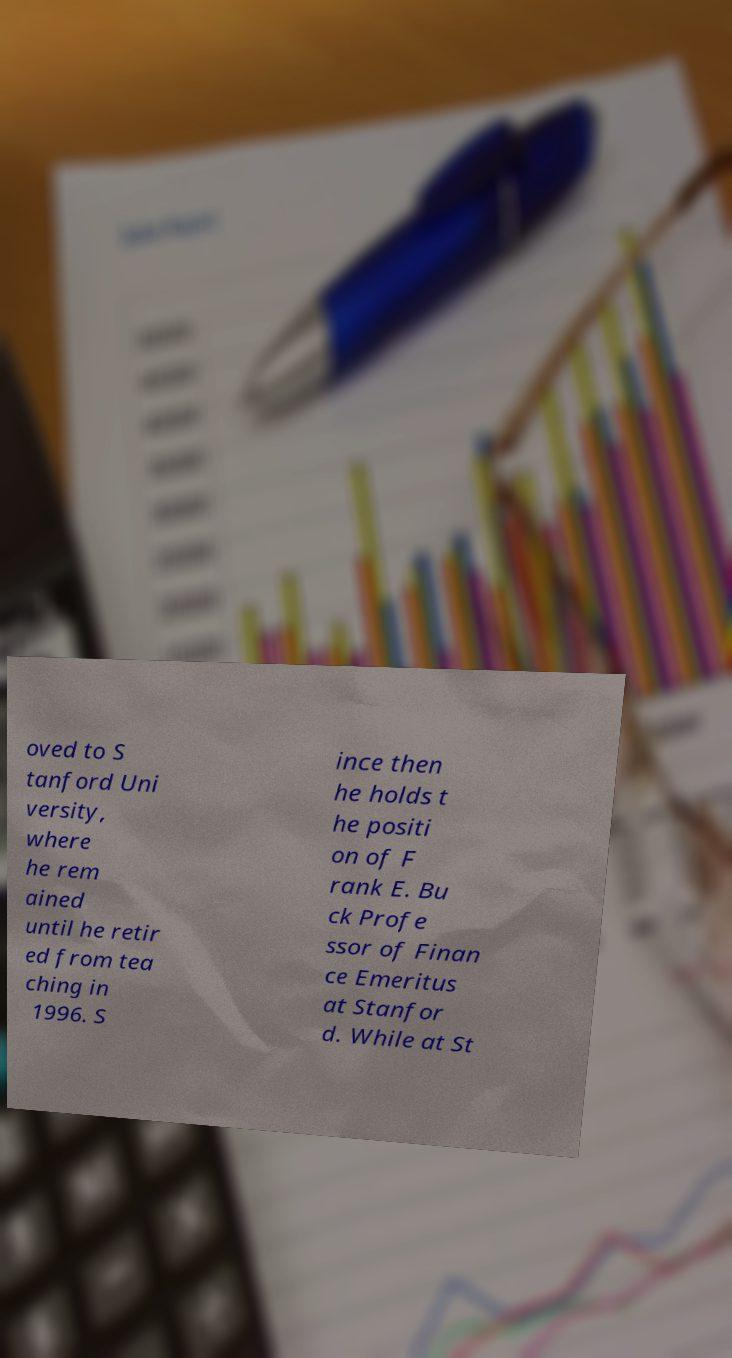Please identify and transcribe the text found in this image. oved to S tanford Uni versity, where he rem ained until he retir ed from tea ching in 1996. S ince then he holds t he positi on of F rank E. Bu ck Profe ssor of Finan ce Emeritus at Stanfor d. While at St 